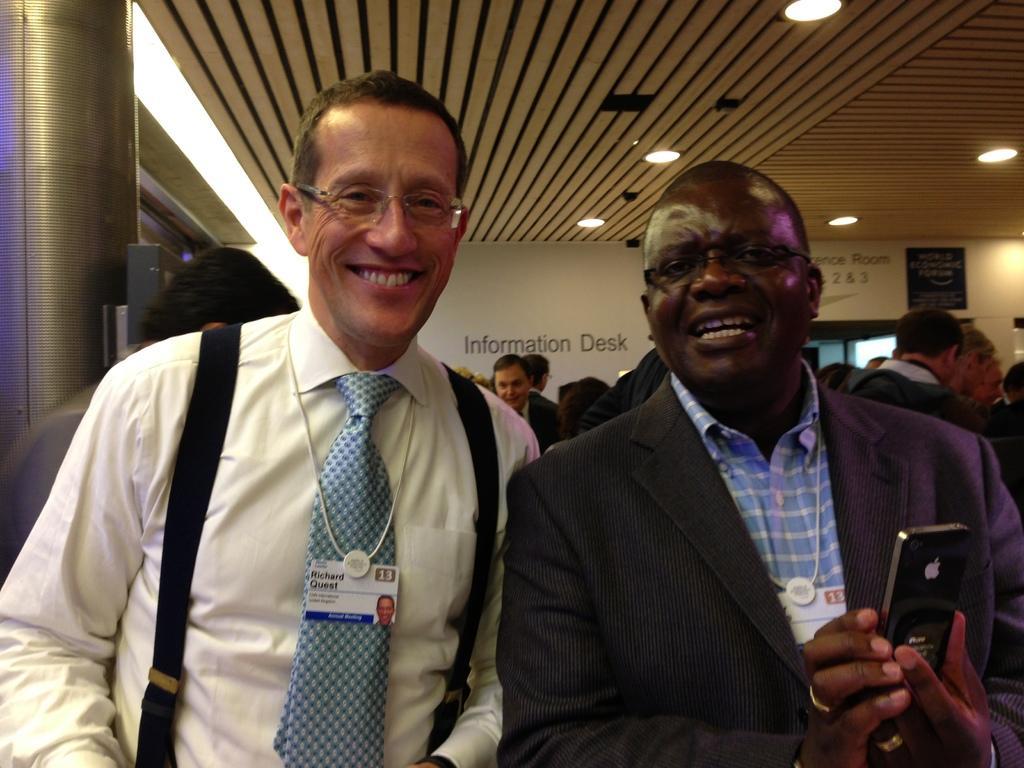Please provide a concise description of this image. In this image I conceive two men and a smile on his face. I can also see both of them are wearing specs and here he is holding a phone. I can also see both of them are wearing ID cards and in the background I can see few more people. 